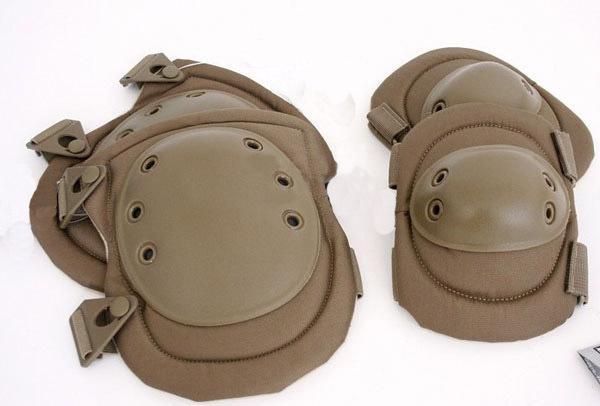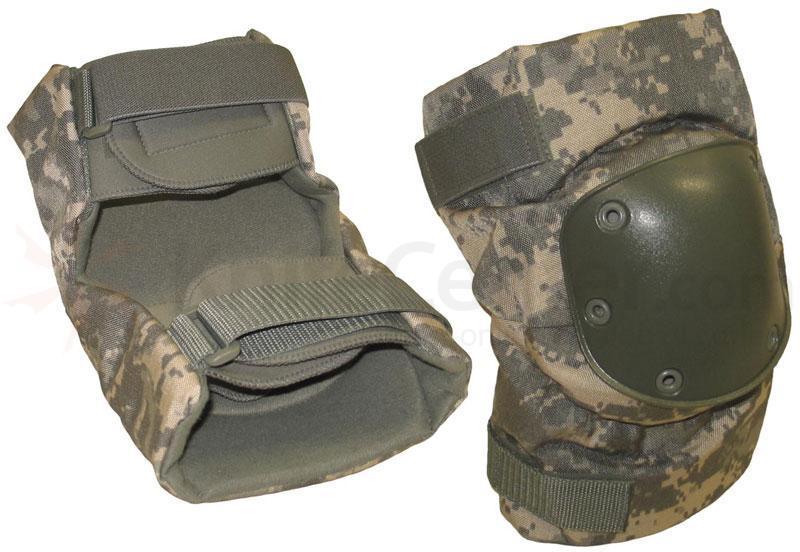The first image is the image on the left, the second image is the image on the right. Assess this claim about the two images: "There are four knee pads facing forward in total.". Correct or not? Answer yes or no. No. The first image is the image on the left, the second image is the image on the right. Considering the images on both sides, is "The kneepads in one image are camouflage and the other image has tan kneepads." valid? Answer yes or no. Yes. 